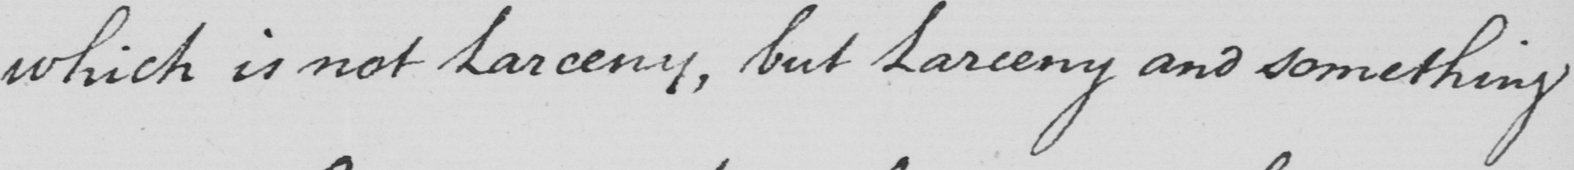Please transcribe the handwritten text in this image. which is not Larceny , but Larceny and something 